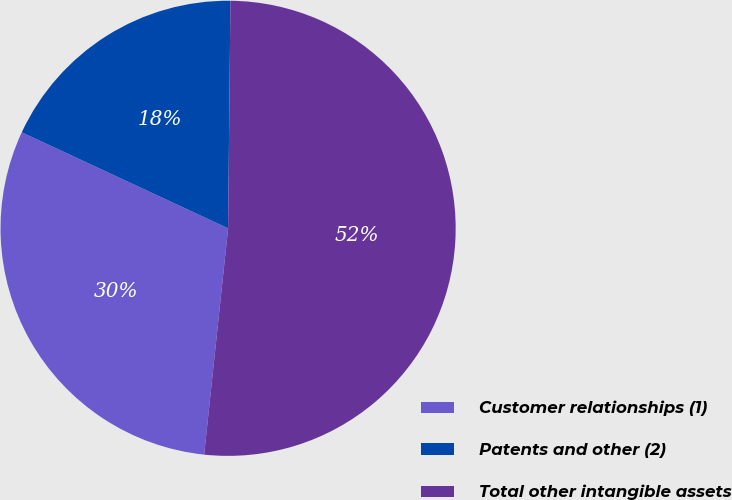Convert chart to OTSL. <chart><loc_0><loc_0><loc_500><loc_500><pie_chart><fcel>Customer relationships (1)<fcel>Patents and other (2)<fcel>Total other intangible assets<nl><fcel>30.25%<fcel>18.23%<fcel>51.51%<nl></chart> 